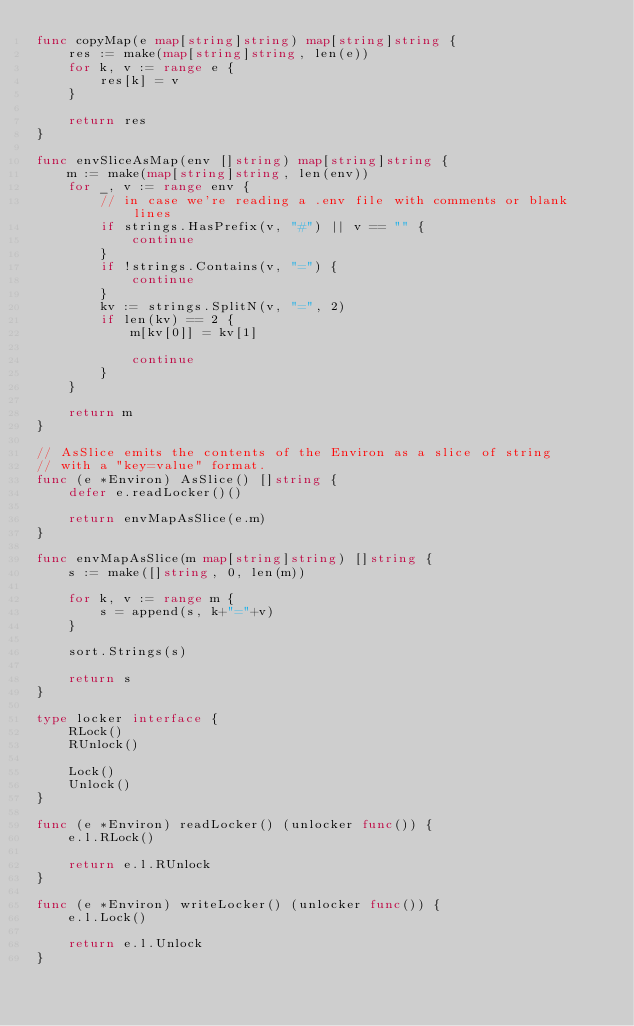<code> <loc_0><loc_0><loc_500><loc_500><_Go_>func copyMap(e map[string]string) map[string]string {
	res := make(map[string]string, len(e))
	for k, v := range e {
		res[k] = v
	}

	return res
}

func envSliceAsMap(env []string) map[string]string {
	m := make(map[string]string, len(env))
	for _, v := range env {
		// in case we're reading a .env file with comments or blank lines
		if strings.HasPrefix(v, "#") || v == "" {
			continue
		}
		if !strings.Contains(v, "=") {
			continue
		}
		kv := strings.SplitN(v, "=", 2)
		if len(kv) == 2 {
			m[kv[0]] = kv[1]

			continue
		}
	}

	return m
}

// AsSlice emits the contents of the Environ as a slice of string
// with a "key=value" format.
func (e *Environ) AsSlice() []string {
	defer e.readLocker()()

	return envMapAsSlice(e.m)
}

func envMapAsSlice(m map[string]string) []string {
	s := make([]string, 0, len(m))

	for k, v := range m {
		s = append(s, k+"="+v)
	}

	sort.Strings(s)

	return s
}

type locker interface {
	RLock()
	RUnlock()

	Lock()
	Unlock()
}

func (e *Environ) readLocker() (unlocker func()) {
	e.l.RLock()

	return e.l.RUnlock
}

func (e *Environ) writeLocker() (unlocker func()) {
	e.l.Lock()

	return e.l.Unlock
}
</code> 